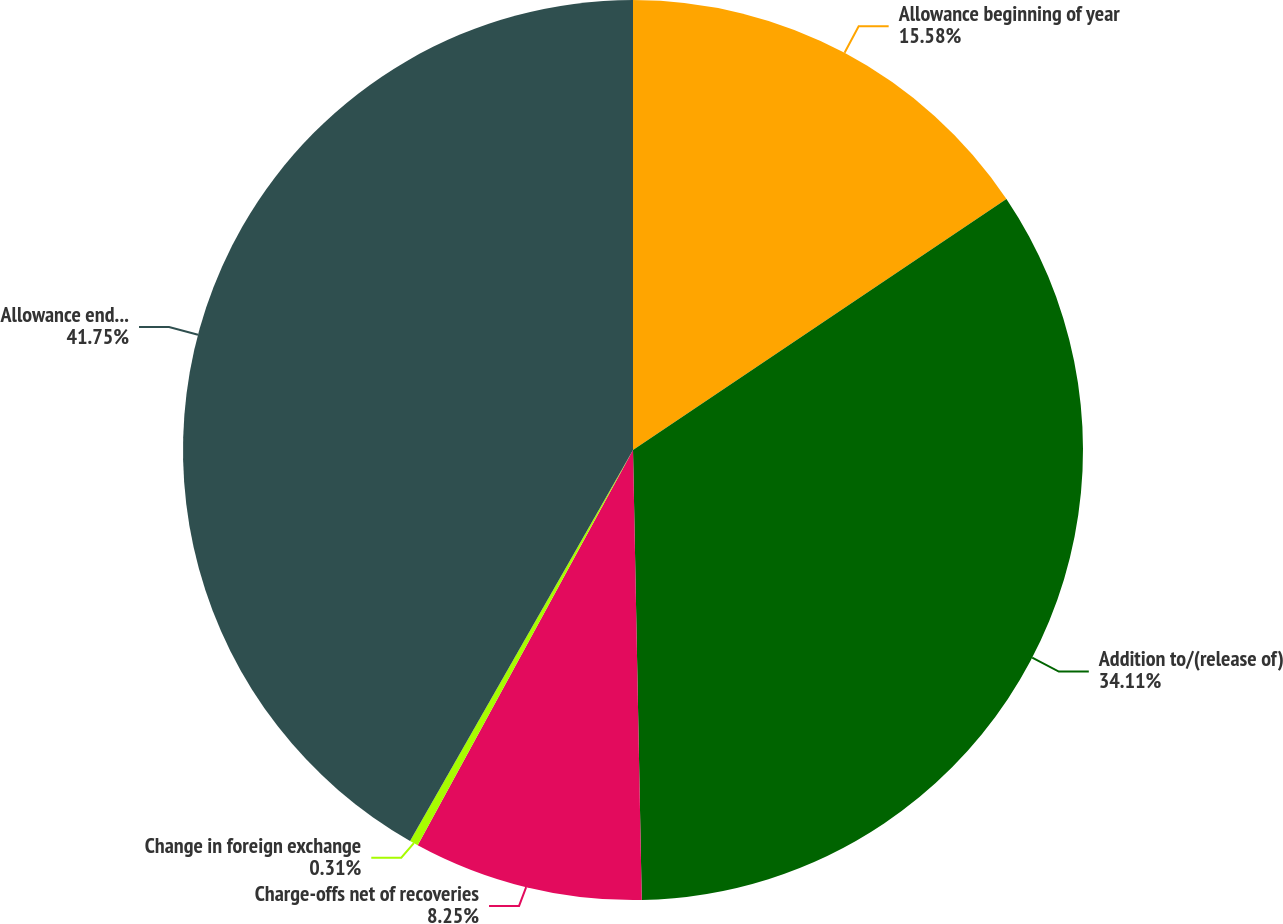Convert chart to OTSL. <chart><loc_0><loc_0><loc_500><loc_500><pie_chart><fcel>Allowance beginning of year<fcel>Addition to/(release of)<fcel>Charge-offs net of recoveries<fcel>Change in foreign exchange<fcel>Allowance end of period<nl><fcel>15.58%<fcel>34.11%<fcel>8.25%<fcel>0.31%<fcel>41.75%<nl></chart> 